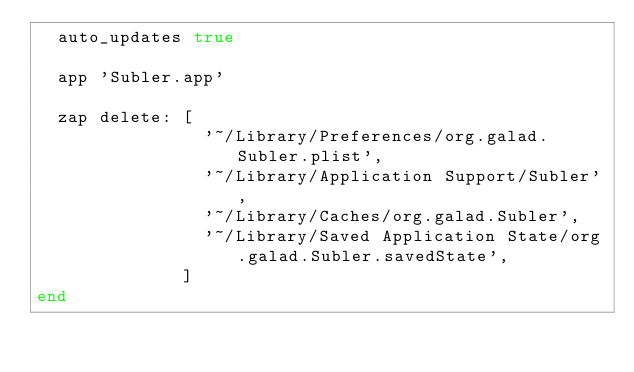Convert code to text. <code><loc_0><loc_0><loc_500><loc_500><_Ruby_>  auto_updates true

  app 'Subler.app'

  zap delete: [
                '~/Library/Preferences/org.galad.Subler.plist',
                '~/Library/Application Support/Subler',
                '~/Library/Caches/org.galad.Subler',
                '~/Library/Saved Application State/org.galad.Subler.savedState',
              ]
end
</code> 